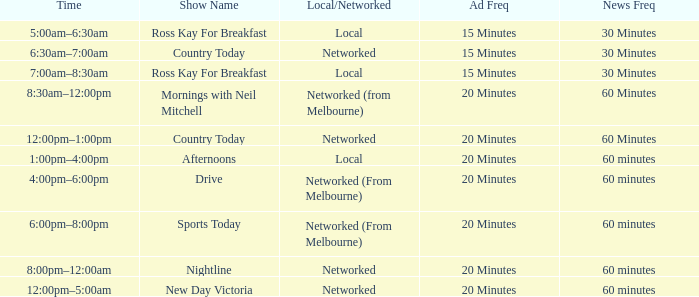What news freq occurs between 1:00pm and 4:00pm? 60 minutes. 